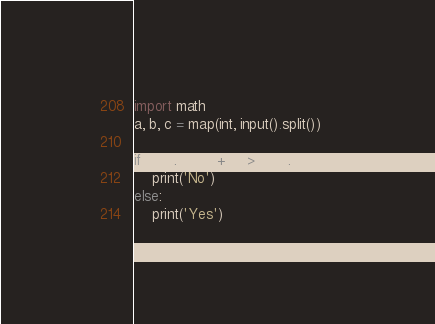<code> <loc_0><loc_0><loc_500><loc_500><_Python_>import math
a, b, c = map(int, input().split())

if math.sqrt(a + b) > math.sqrt(c):
    print('No')
else:
    print('Yes')</code> 